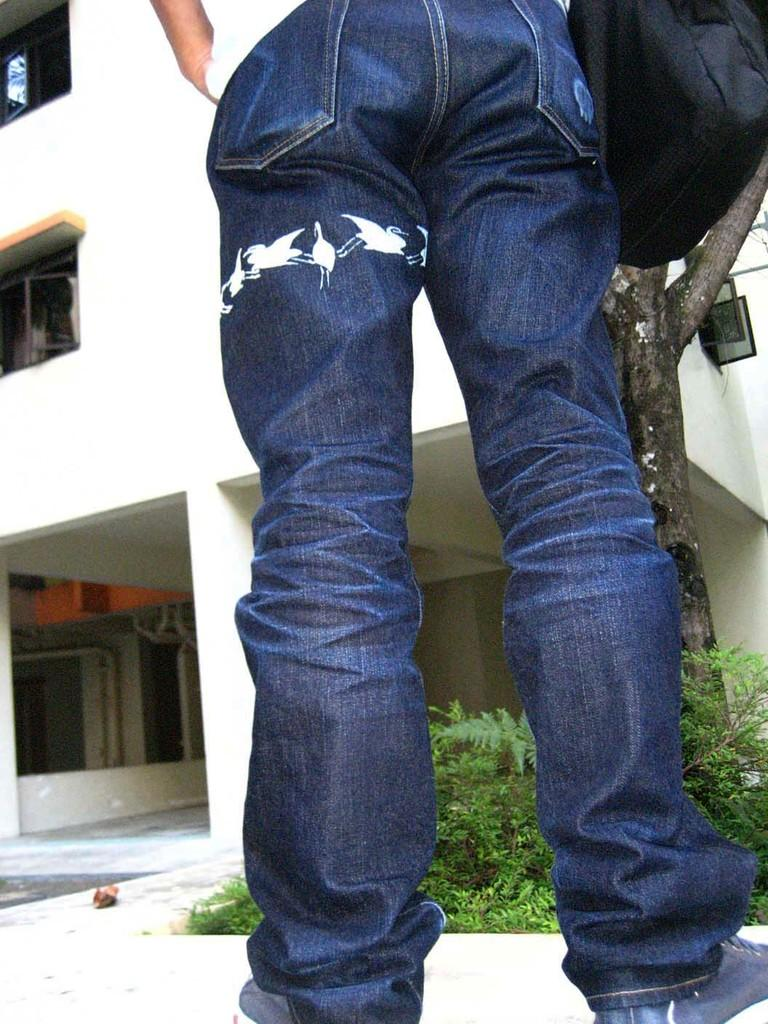Who or what is present in the image? There is a person in the image. What can be seen beneath the person's feet? The ground is visible in the image. What type of natural elements are present in the image? There are plants and the trunk of a tree visible in the image. What type of man-made structure is present in the image? There is a building in the image. What is the color of the object on the right side of the image? There is a black colored object on the right side of the image. What type of hat is the person wearing in the image? There is no hat visible in the image. What type of sponge can be seen in the image? There is no sponge present in the image. 